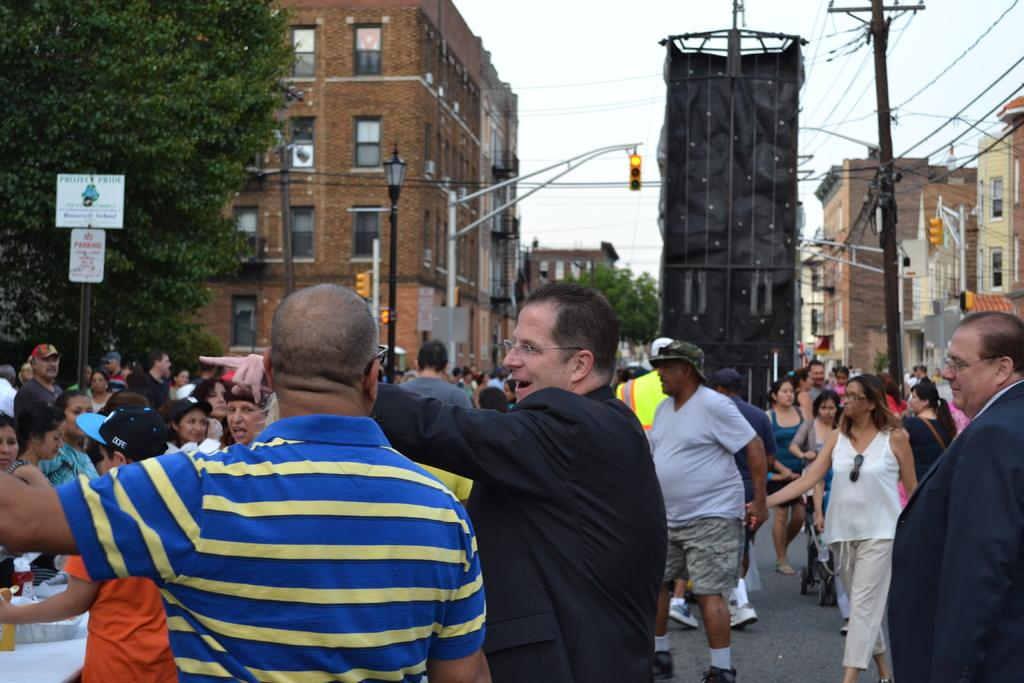What can be seen on the path in the image? There are many people on the path in the image. What helps regulate traffic in the image? There are traffic signals in the image. What else can be seen in the image besides people and traffic signals? There are wires, a tree, a streetlight, and a few buildings visible in the background of the image. What type of pets are walking with their partners on the path in the image? There are no pets or partners present in the image; it features people walking on a path with traffic signals, wires, a tree, a streetlight, and a few buildings visible in the background. 